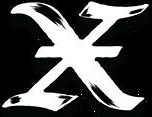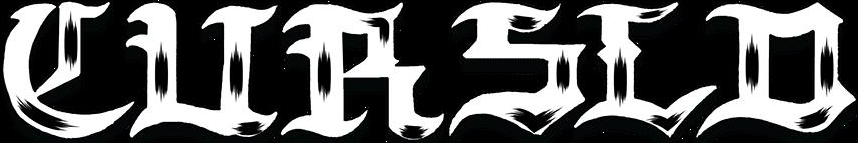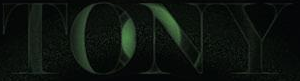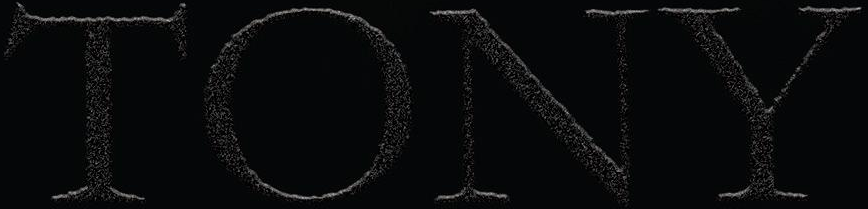What text appears in these images from left to right, separated by a semicolon? X; CURSLD; TONY; TONY 